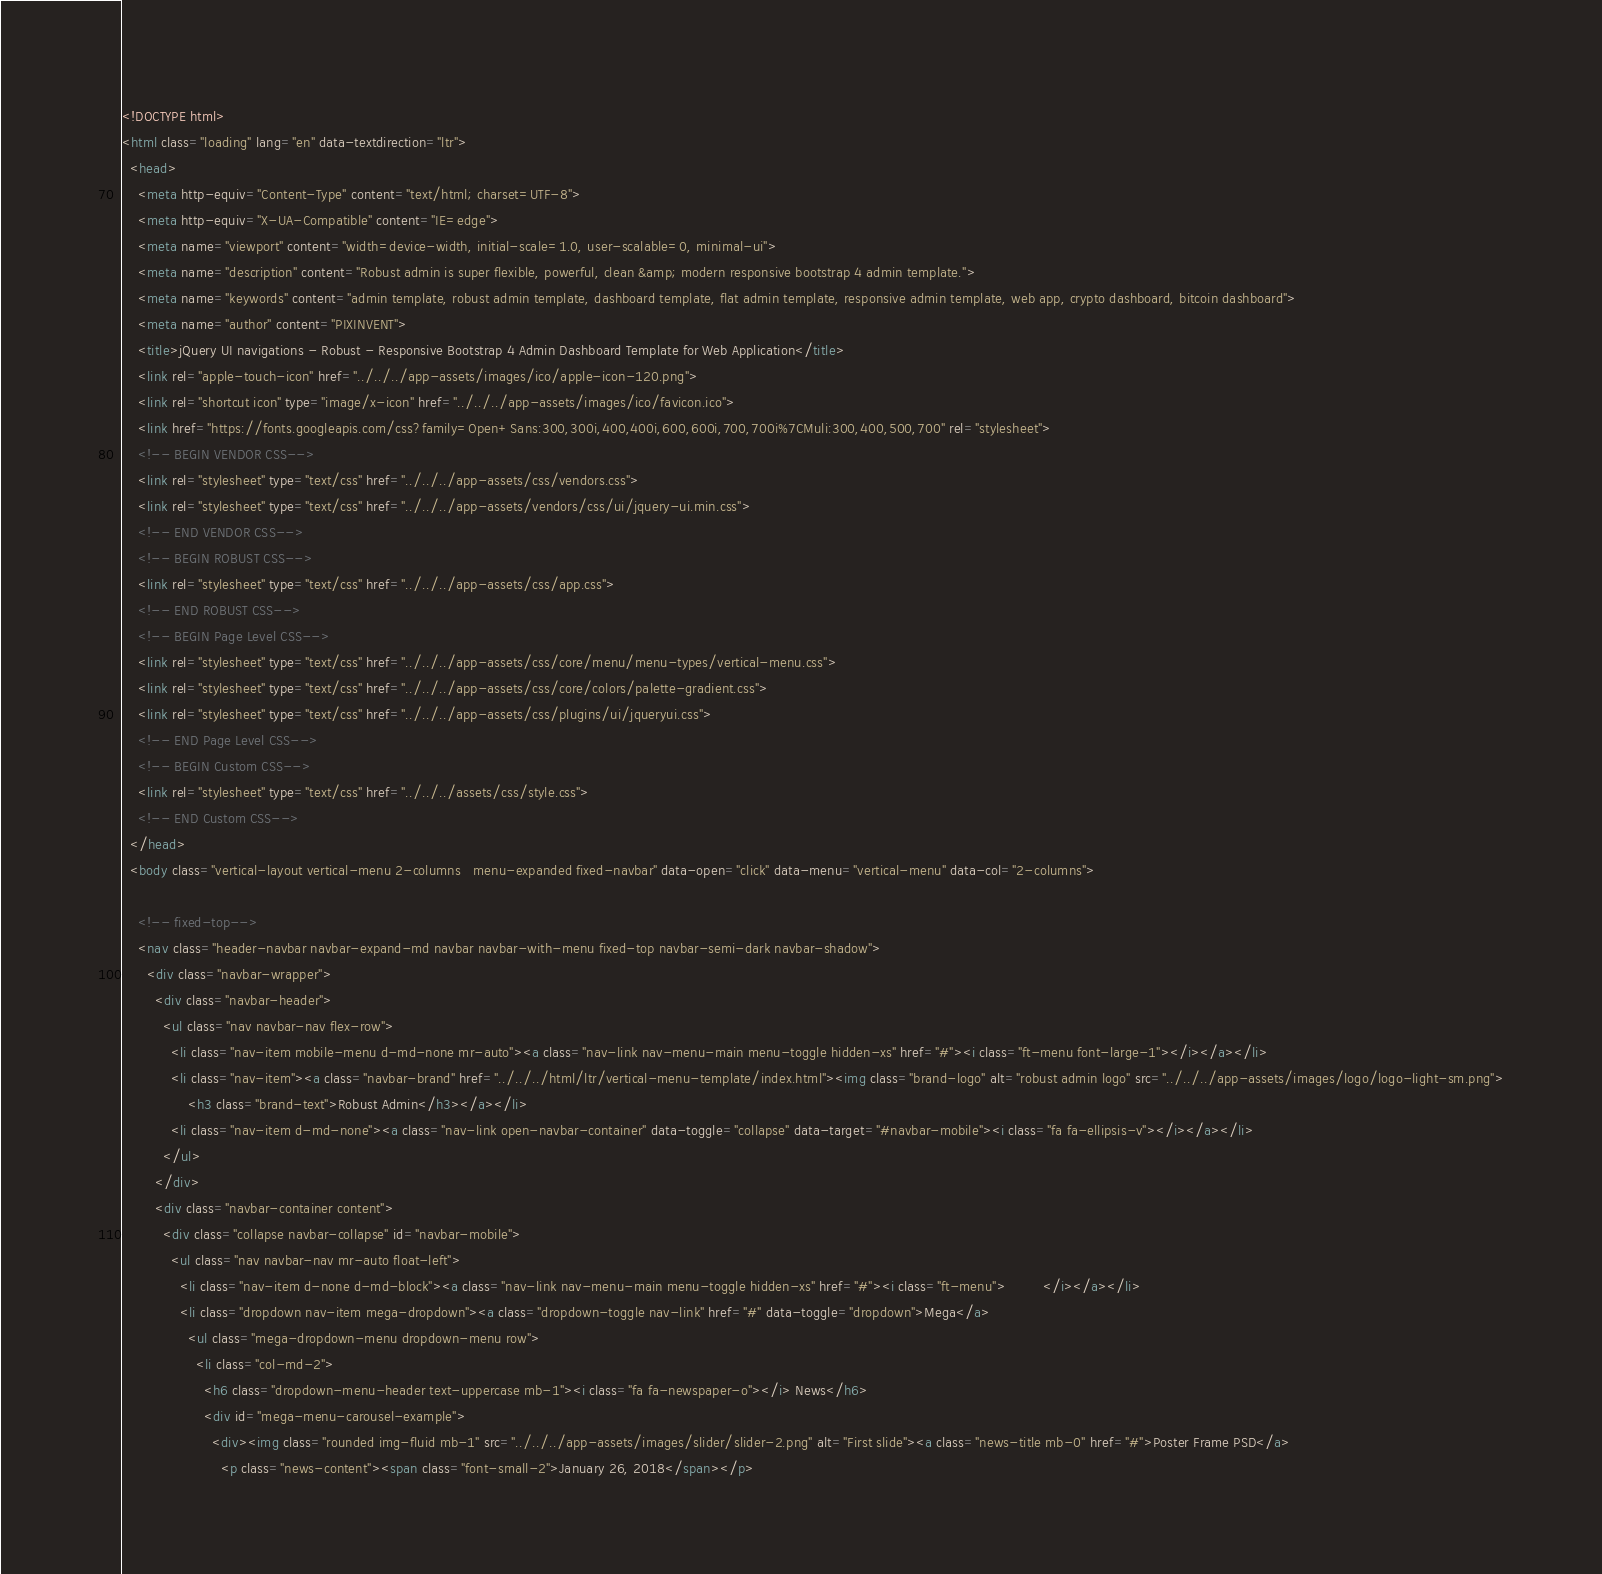<code> <loc_0><loc_0><loc_500><loc_500><_HTML_><!DOCTYPE html>
<html class="loading" lang="en" data-textdirection="ltr">
  <head>
    <meta http-equiv="Content-Type" content="text/html; charset=UTF-8">
    <meta http-equiv="X-UA-Compatible" content="IE=edge">
    <meta name="viewport" content="width=device-width, initial-scale=1.0, user-scalable=0, minimal-ui">
    <meta name="description" content="Robust admin is super flexible, powerful, clean &amp; modern responsive bootstrap 4 admin template.">
    <meta name="keywords" content="admin template, robust admin template, dashboard template, flat admin template, responsive admin template, web app, crypto dashboard, bitcoin dashboard">
    <meta name="author" content="PIXINVENT">
    <title>jQuery UI navigations - Robust - Responsive Bootstrap 4 Admin Dashboard Template for Web Application</title>
    <link rel="apple-touch-icon" href="../../../app-assets/images/ico/apple-icon-120.png">
    <link rel="shortcut icon" type="image/x-icon" href="../../../app-assets/images/ico/favicon.ico">
    <link href="https://fonts.googleapis.com/css?family=Open+Sans:300,300i,400,400i,600,600i,700,700i%7CMuli:300,400,500,700" rel="stylesheet">
    <!-- BEGIN VENDOR CSS-->
    <link rel="stylesheet" type="text/css" href="../../../app-assets/css/vendors.css">
    <link rel="stylesheet" type="text/css" href="../../../app-assets/vendors/css/ui/jquery-ui.min.css">
    <!-- END VENDOR CSS-->
    <!-- BEGIN ROBUST CSS-->
    <link rel="stylesheet" type="text/css" href="../../../app-assets/css/app.css">
    <!-- END ROBUST CSS-->
    <!-- BEGIN Page Level CSS-->
    <link rel="stylesheet" type="text/css" href="../../../app-assets/css/core/menu/menu-types/vertical-menu.css">
    <link rel="stylesheet" type="text/css" href="../../../app-assets/css/core/colors/palette-gradient.css">
    <link rel="stylesheet" type="text/css" href="../../../app-assets/css/plugins/ui/jqueryui.css">
    <!-- END Page Level CSS-->
    <!-- BEGIN Custom CSS-->
    <link rel="stylesheet" type="text/css" href="../../../assets/css/style.css">
    <!-- END Custom CSS-->
  </head>
  <body class="vertical-layout vertical-menu 2-columns   menu-expanded fixed-navbar" data-open="click" data-menu="vertical-menu" data-col="2-columns">

    <!-- fixed-top-->
    <nav class="header-navbar navbar-expand-md navbar navbar-with-menu fixed-top navbar-semi-dark navbar-shadow">
      <div class="navbar-wrapper">
        <div class="navbar-header">
          <ul class="nav navbar-nav flex-row">
            <li class="nav-item mobile-menu d-md-none mr-auto"><a class="nav-link nav-menu-main menu-toggle hidden-xs" href="#"><i class="ft-menu font-large-1"></i></a></li>
            <li class="nav-item"><a class="navbar-brand" href="../../../html/ltr/vertical-menu-template/index.html"><img class="brand-logo" alt="robust admin logo" src="../../../app-assets/images/logo/logo-light-sm.png">
                <h3 class="brand-text">Robust Admin</h3></a></li>
            <li class="nav-item d-md-none"><a class="nav-link open-navbar-container" data-toggle="collapse" data-target="#navbar-mobile"><i class="fa fa-ellipsis-v"></i></a></li>
          </ul>
        </div>
        <div class="navbar-container content">
          <div class="collapse navbar-collapse" id="navbar-mobile">
            <ul class="nav navbar-nav mr-auto float-left">
              <li class="nav-item d-none d-md-block"><a class="nav-link nav-menu-main menu-toggle hidden-xs" href="#"><i class="ft-menu">         </i></a></li>
              <li class="dropdown nav-item mega-dropdown"><a class="dropdown-toggle nav-link" href="#" data-toggle="dropdown">Mega</a>
                <ul class="mega-dropdown-menu dropdown-menu row">
                  <li class="col-md-2">
                    <h6 class="dropdown-menu-header text-uppercase mb-1"><i class="fa fa-newspaper-o"></i> News</h6>
                    <div id="mega-menu-carousel-example">
                      <div><img class="rounded img-fluid mb-1" src="../../../app-assets/images/slider/slider-2.png" alt="First slide"><a class="news-title mb-0" href="#">Poster Frame PSD</a>
                        <p class="news-content"><span class="font-small-2">January 26, 2018</span></p></code> 